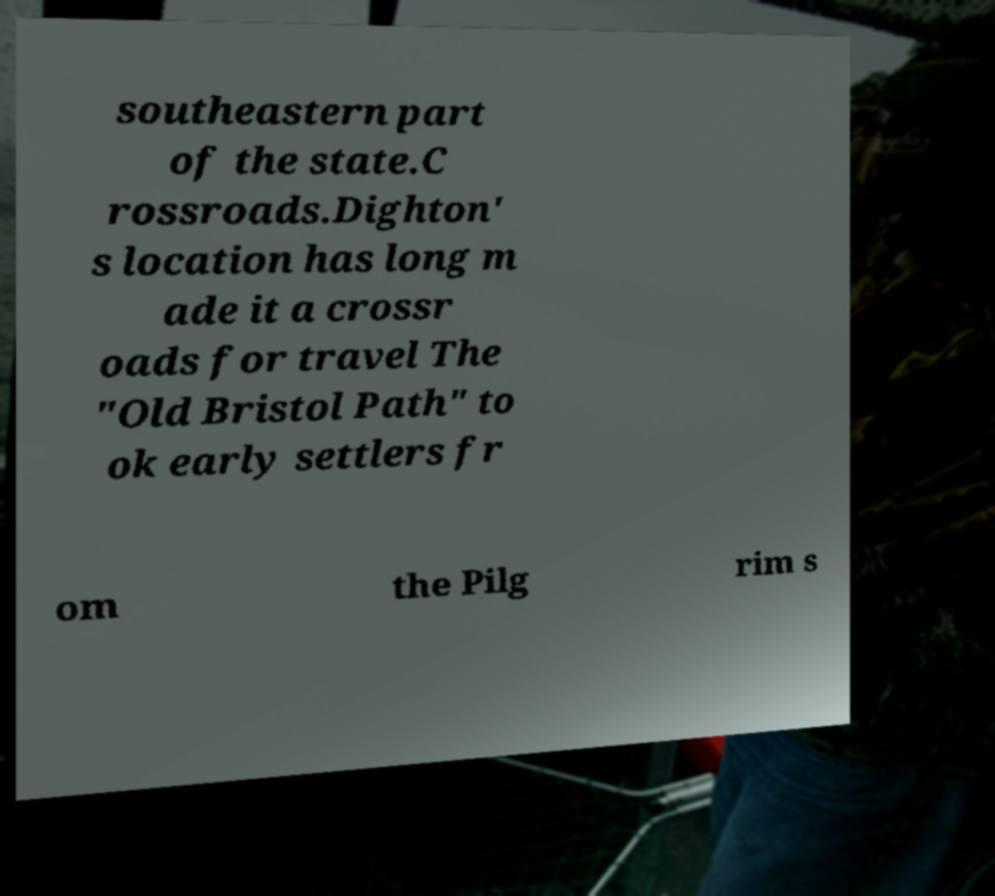What messages or text are displayed in this image? I need them in a readable, typed format. southeastern part of the state.C rossroads.Dighton' s location has long m ade it a crossr oads for travel The "Old Bristol Path" to ok early settlers fr om the Pilg rim s 